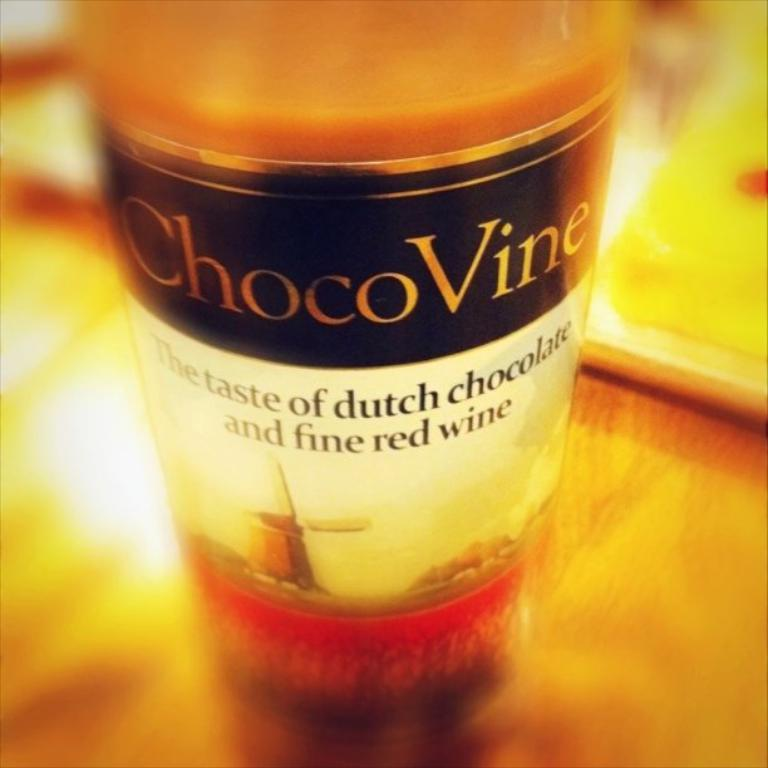<image>
Present a compact description of the photo's key features. A bottle of ChocoVine is displayed with the words "The Taste of dutch chocolate and fine red wine" on the label. 